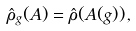<formula> <loc_0><loc_0><loc_500><loc_500>\hat { \rho } _ { g } ( A ) = \hat { \rho } ( A ( g ) ) \, ,</formula> 